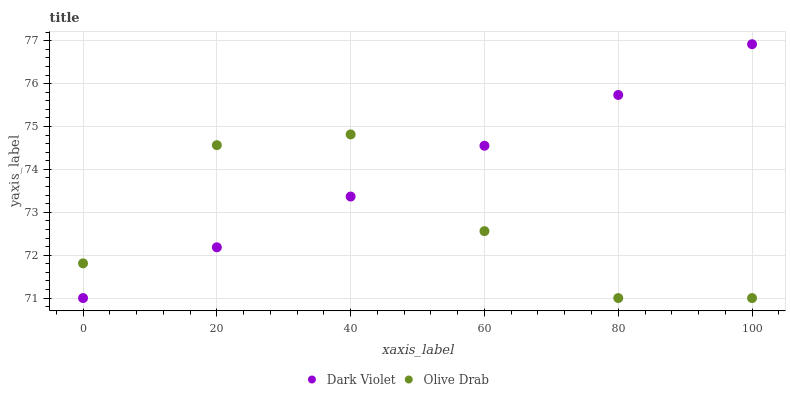Does Olive Drab have the minimum area under the curve?
Answer yes or no. Yes. Does Dark Violet have the maximum area under the curve?
Answer yes or no. Yes. Does Dark Violet have the minimum area under the curve?
Answer yes or no. No. Is Dark Violet the smoothest?
Answer yes or no. Yes. Is Olive Drab the roughest?
Answer yes or no. Yes. Is Dark Violet the roughest?
Answer yes or no. No. Does Olive Drab have the lowest value?
Answer yes or no. Yes. Does Dark Violet have the highest value?
Answer yes or no. Yes. Does Dark Violet intersect Olive Drab?
Answer yes or no. Yes. Is Dark Violet less than Olive Drab?
Answer yes or no. No. Is Dark Violet greater than Olive Drab?
Answer yes or no. No. 